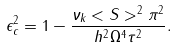<formula> <loc_0><loc_0><loc_500><loc_500>\epsilon _ { c } ^ { 2 } = 1 - \frac { \nu _ { k } < S > ^ { 2 } \pi ^ { 2 } } { h ^ { 2 } \Omega ^ { 4 } \tau ^ { 2 } } .</formula> 